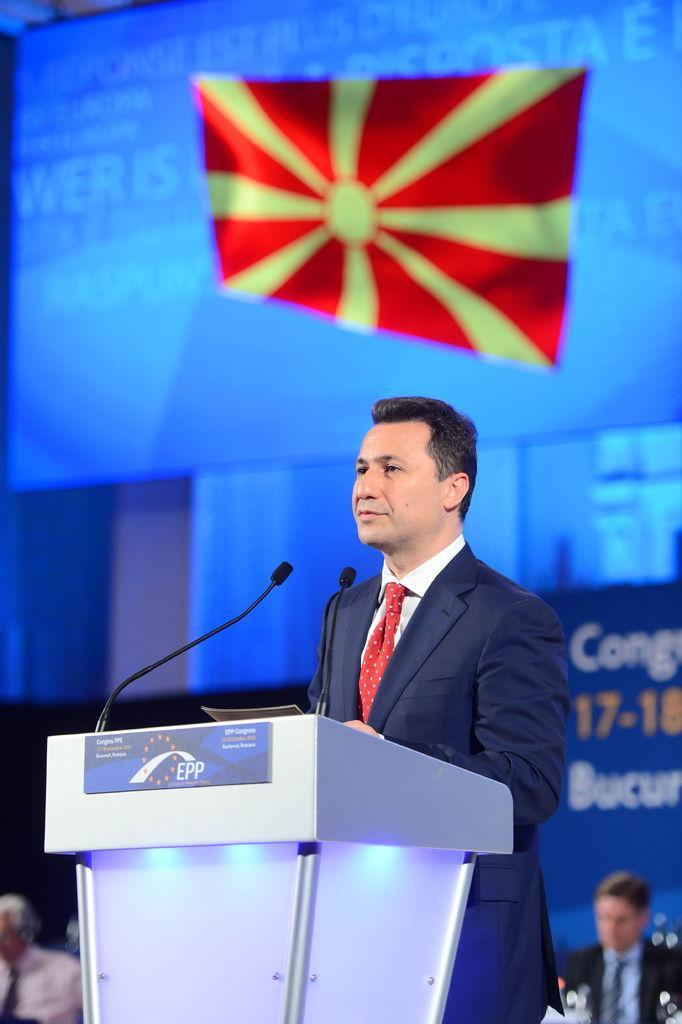Could you give a brief overview of what you see in this image? In this image there is a person standing in front of the dais. On top of the days there are two mikes and a paper. Behind him there are few other people. In the background of the image there is a screen. There are banners. 